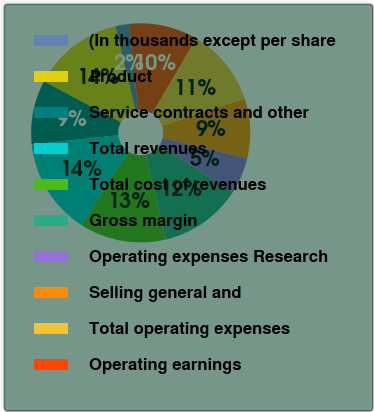Convert chart to OTSL. <chart><loc_0><loc_0><loc_500><loc_500><pie_chart><fcel>(In thousands except per share<fcel>Product<fcel>Service contracts and other<fcel>Total revenues<fcel>Total cost of revenues<fcel>Gross margin<fcel>Operating expenses Research<fcel>Selling general and<fcel>Total operating expenses<fcel>Operating earnings<nl><fcel>2.03%<fcel>13.51%<fcel>9.46%<fcel>14.19%<fcel>12.84%<fcel>12.16%<fcel>5.41%<fcel>8.78%<fcel>11.49%<fcel>10.14%<nl></chart> 